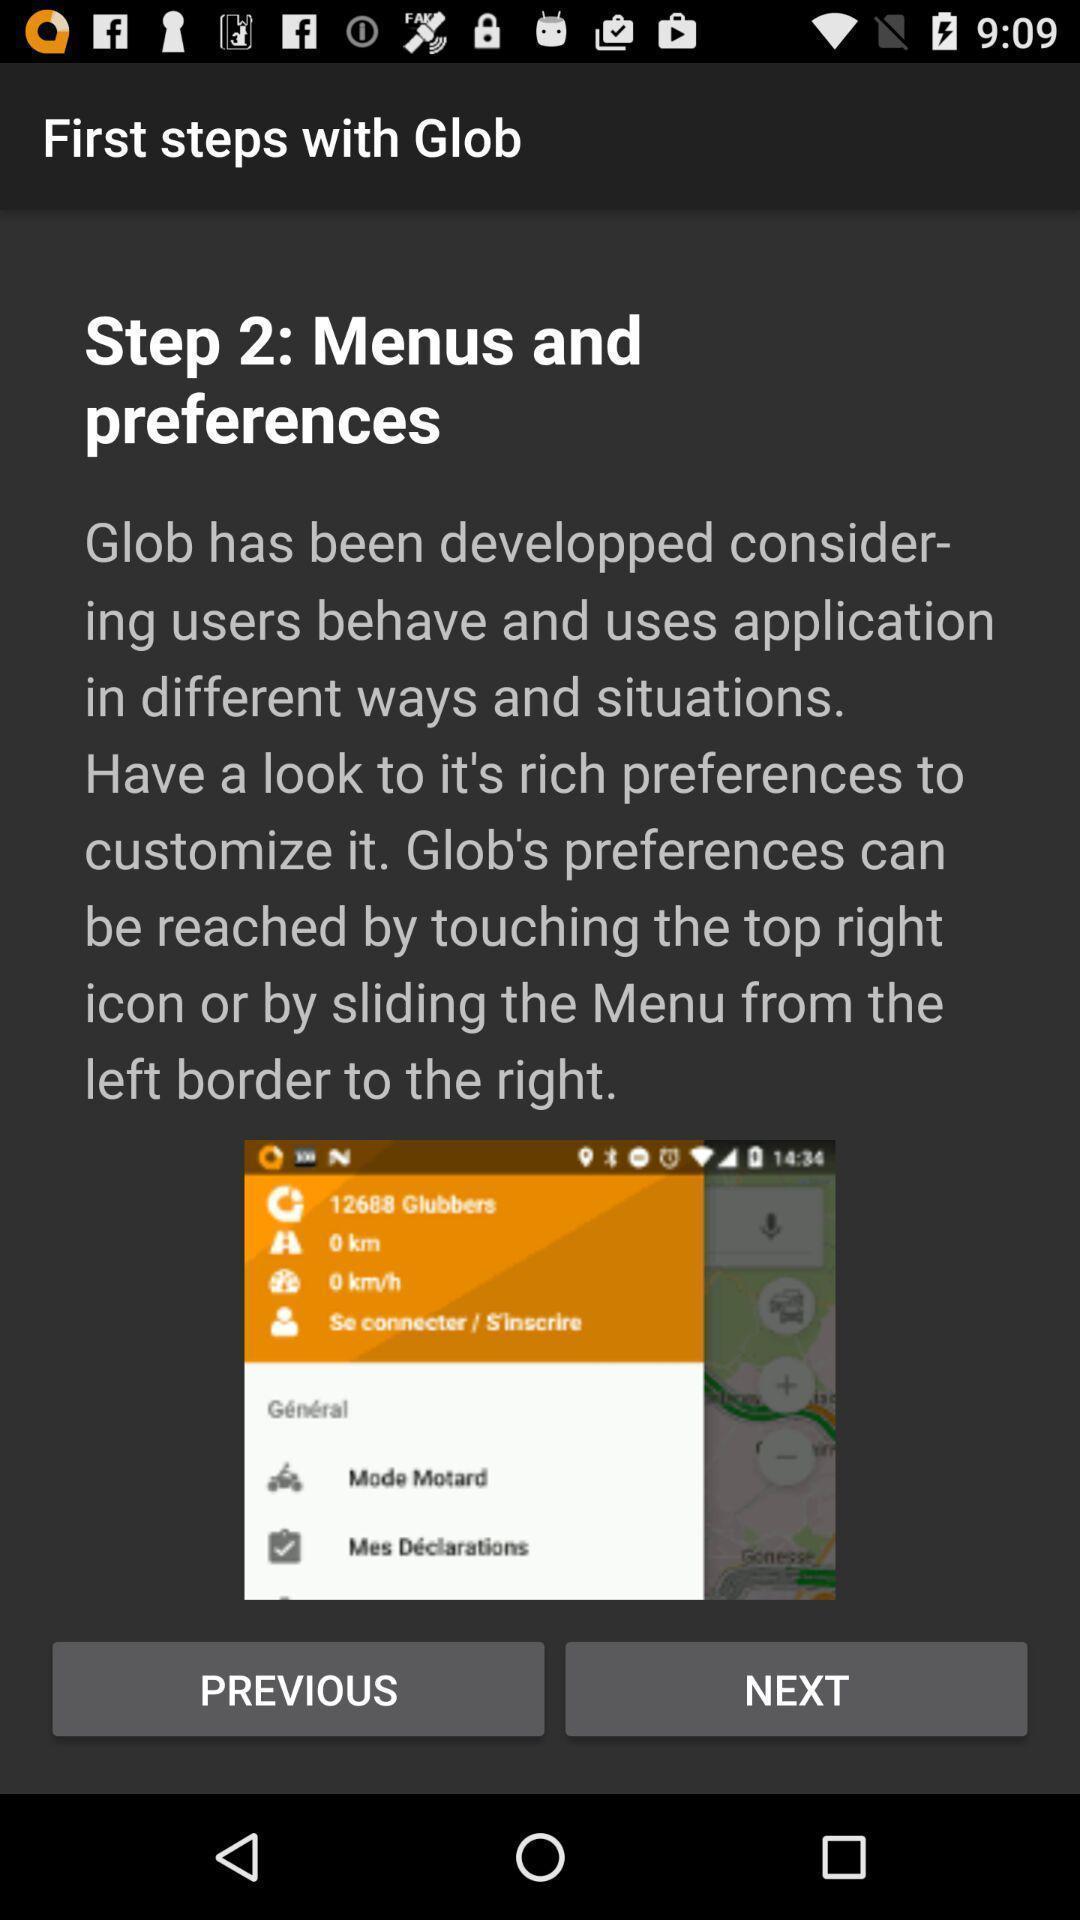Please provide a description for this image. Page showing information about the location tracking app. 